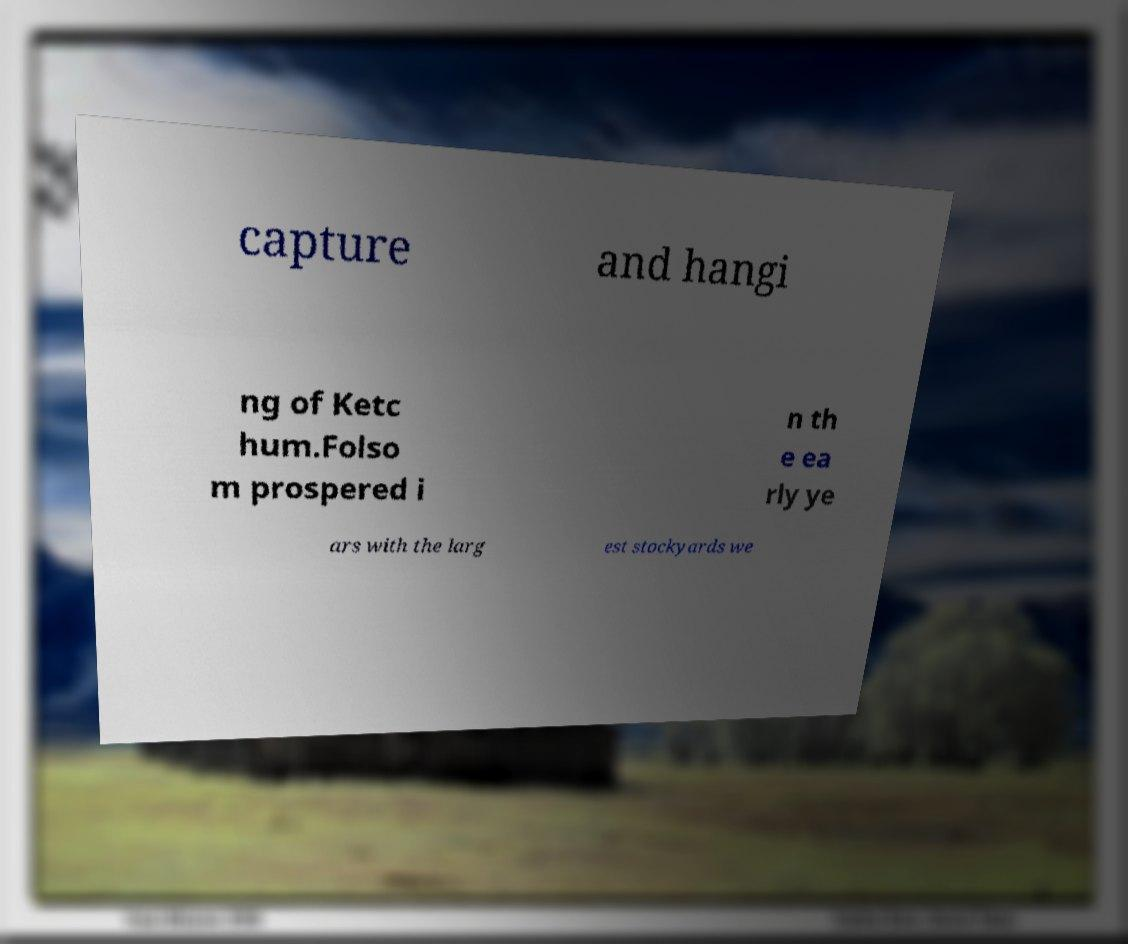Could you extract and type out the text from this image? capture and hangi ng of Ketc hum.Folso m prospered i n th e ea rly ye ars with the larg est stockyards we 